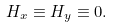Convert formula to latex. <formula><loc_0><loc_0><loc_500><loc_500>H _ { x } \equiv H _ { y } \equiv 0 .</formula> 